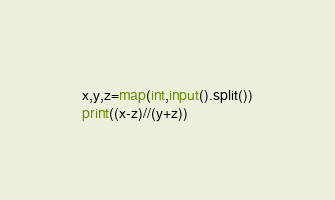<code> <loc_0><loc_0><loc_500><loc_500><_Python_>x,y,z=map(int,input().split())
print((x-z)//(y+z))
</code> 